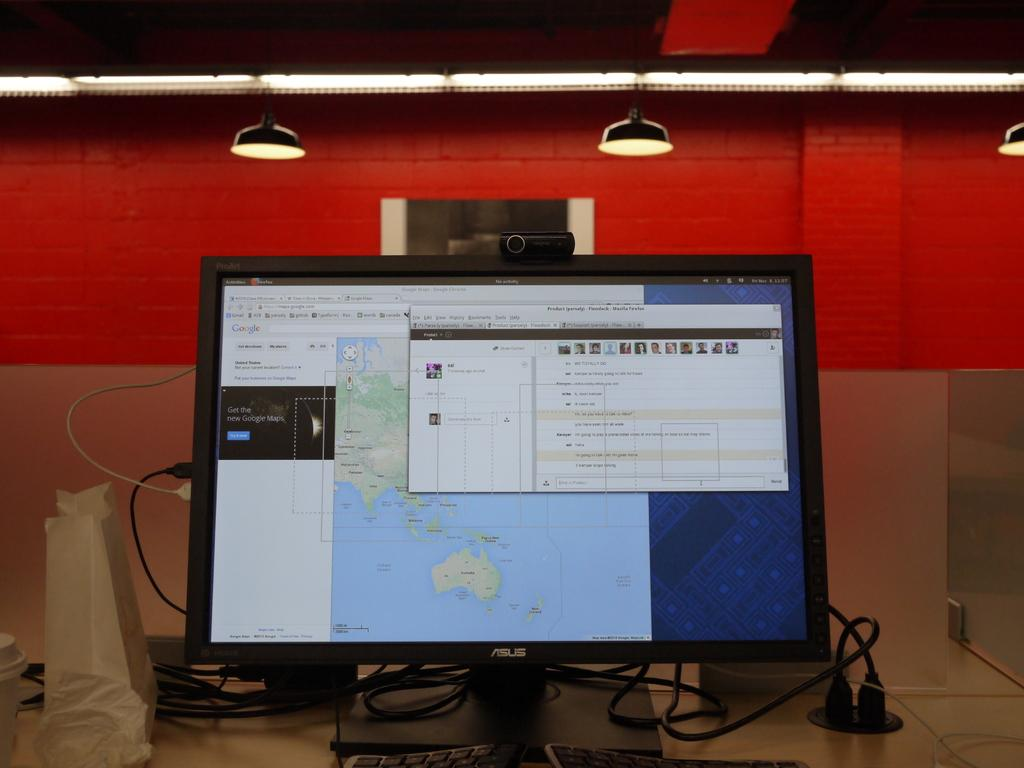<image>
Give a short and clear explanation of the subsequent image. An ASUS monitor is showing the result from Google Maps. 